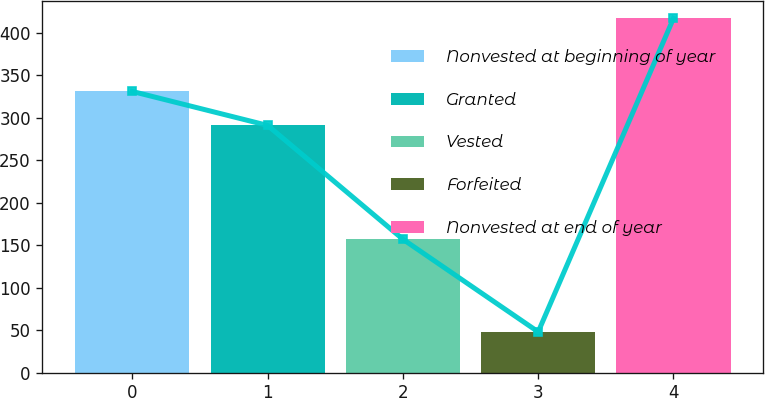Convert chart. <chart><loc_0><loc_0><loc_500><loc_500><bar_chart><fcel>Nonvested at beginning of year<fcel>Granted<fcel>Vested<fcel>Forfeited<fcel>Nonvested at end of year<nl><fcel>331<fcel>291<fcel>157<fcel>48<fcel>417<nl></chart> 